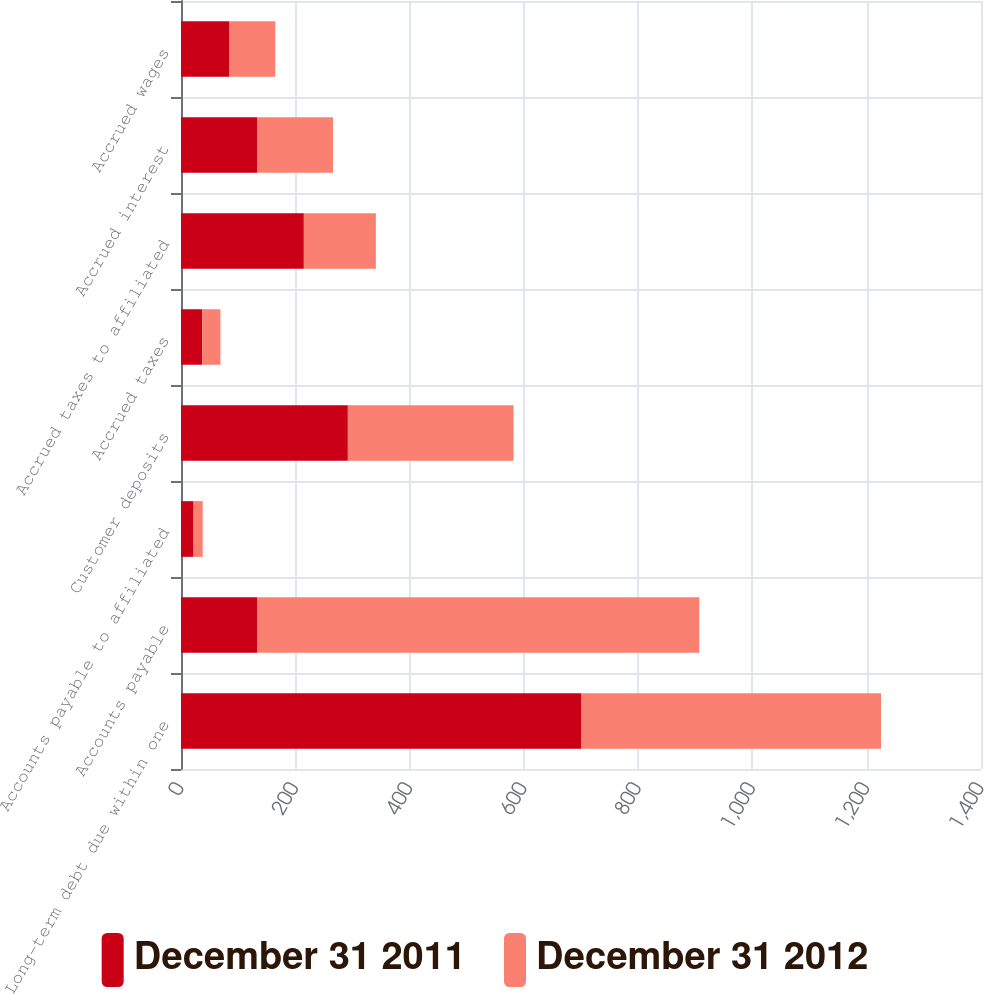<chart> <loc_0><loc_0><loc_500><loc_500><stacked_bar_chart><ecel><fcel>Long-term debt due within one<fcel>Accounts payable<fcel>Accounts payable to affiliated<fcel>Customer deposits<fcel>Accrued taxes<fcel>Accrued taxes to affiliated<fcel>Accrued interest<fcel>Accrued wages<nl><fcel>December 31 2011<fcel>700<fcel>133<fcel>22<fcel>292<fcel>37<fcel>215<fcel>133<fcel>84<nl><fcel>December 31 2012<fcel>525<fcel>774<fcel>16<fcel>290<fcel>32<fcel>126<fcel>133<fcel>81<nl></chart> 